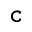Convert formula to latex. <formula><loc_0><loc_0><loc_500><loc_500>_ { c }</formula> 